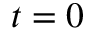Convert formula to latex. <formula><loc_0><loc_0><loc_500><loc_500>t = 0</formula> 